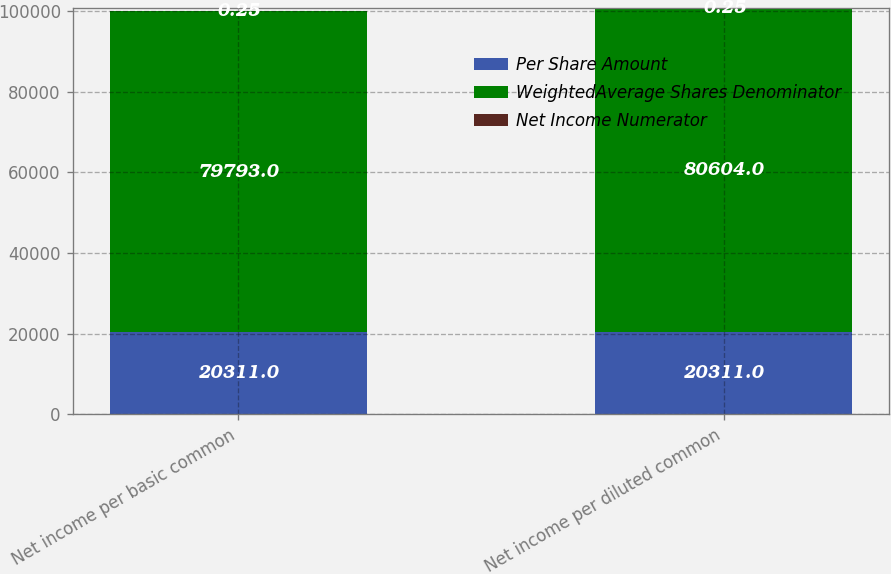Convert chart to OTSL. <chart><loc_0><loc_0><loc_500><loc_500><stacked_bar_chart><ecel><fcel>Net income per basic common<fcel>Net income per diluted common<nl><fcel>Per Share Amount<fcel>20311<fcel>20311<nl><fcel>WeightedAverage Shares Denominator<fcel>79793<fcel>80604<nl><fcel>Net Income Numerator<fcel>0.25<fcel>0.25<nl></chart> 